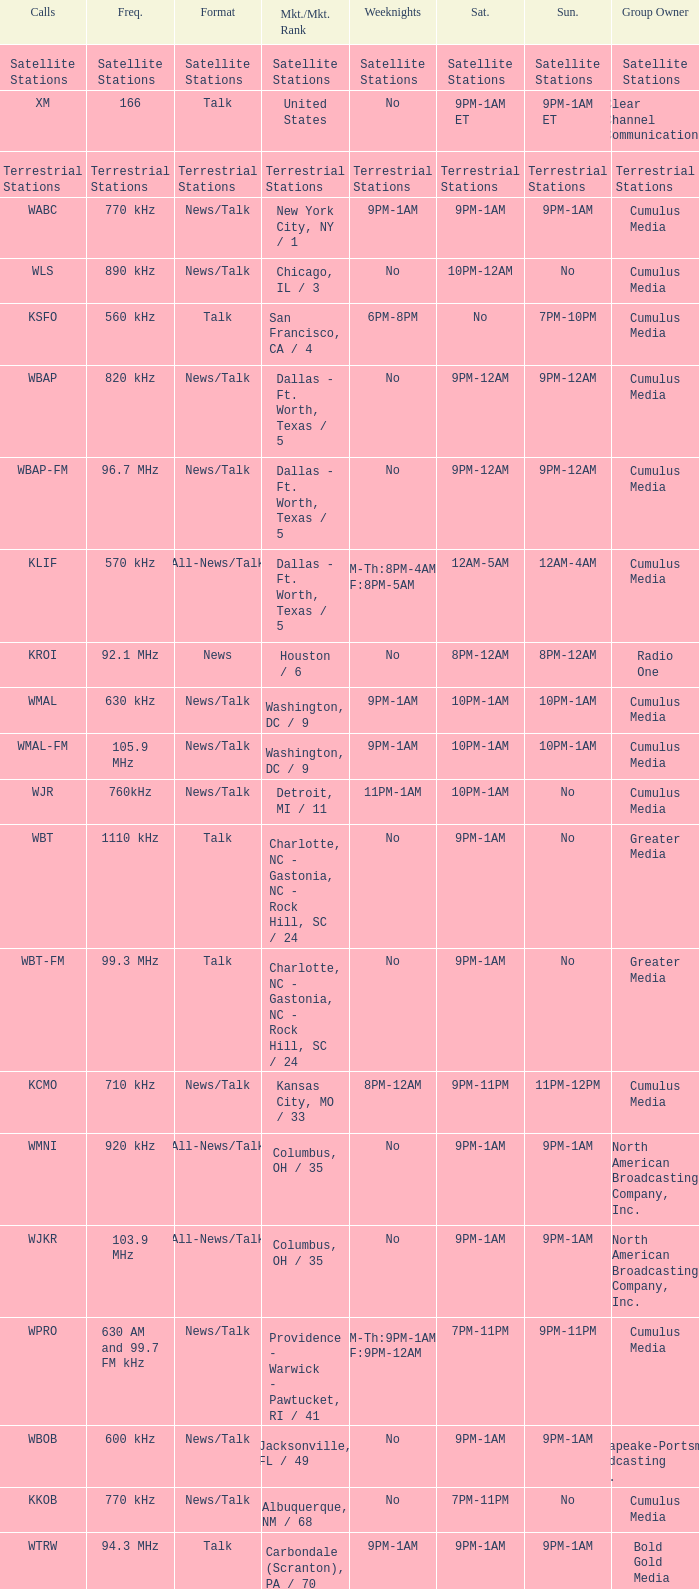What is the market for the 11pm-1am Saturday game? Chattanooga, TN / 108. 